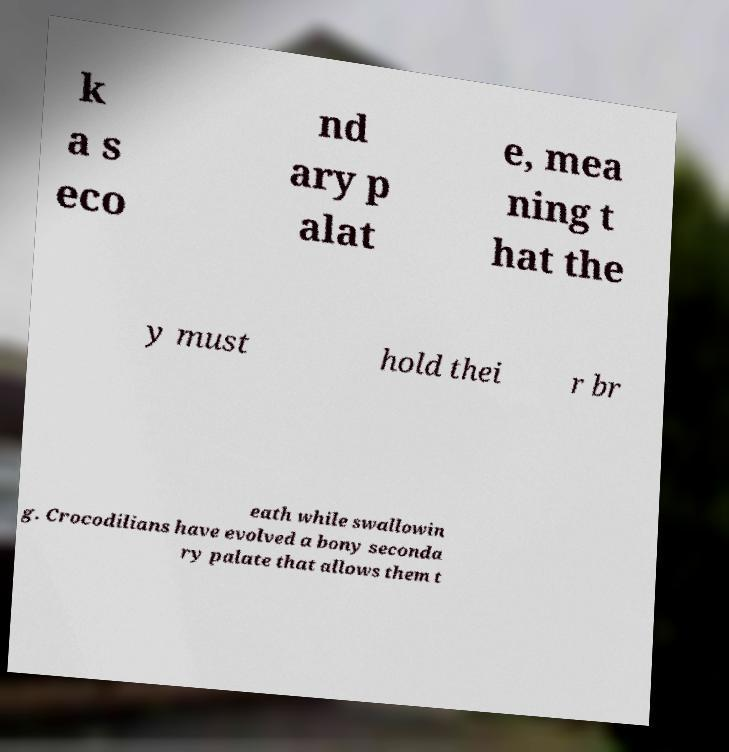There's text embedded in this image that I need extracted. Can you transcribe it verbatim? k a s eco nd ary p alat e, mea ning t hat the y must hold thei r br eath while swallowin g. Crocodilians have evolved a bony seconda ry palate that allows them t 